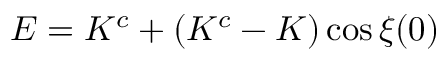<formula> <loc_0><loc_0><loc_500><loc_500>E = K ^ { c } + ( K ^ { c } - K ) \cos \xi ( 0 )</formula> 